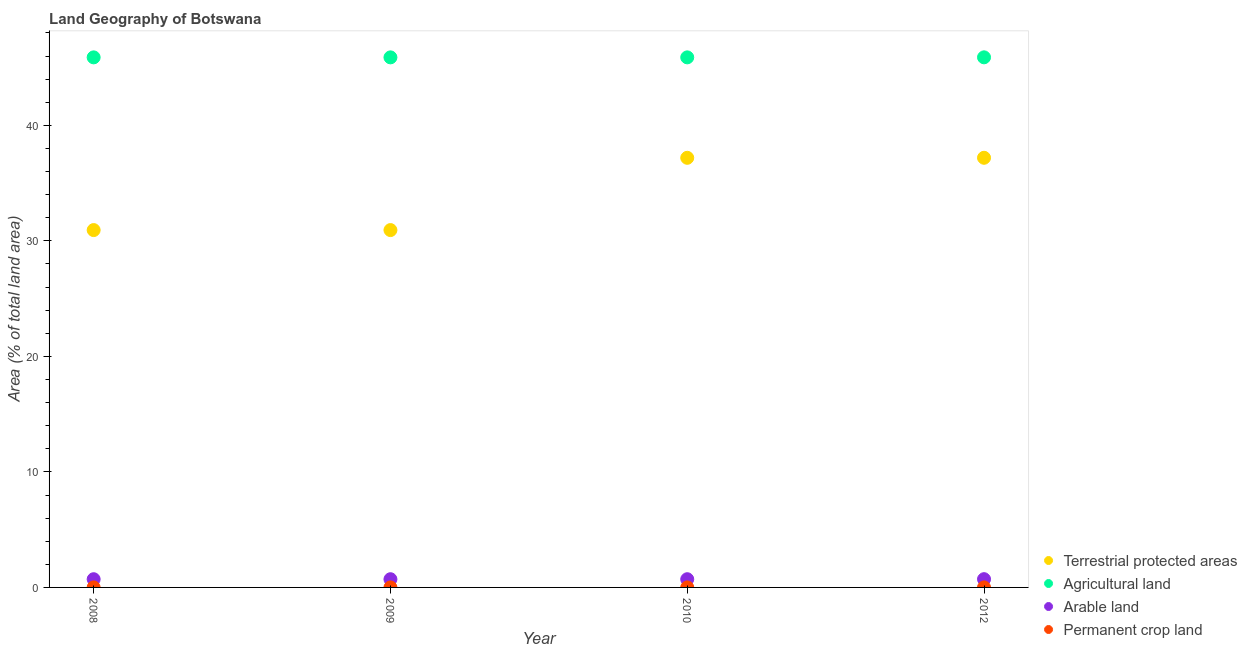Is the number of dotlines equal to the number of legend labels?
Ensure brevity in your answer.  Yes. What is the percentage of area under permanent crop land in 2012?
Give a very brief answer. 0. Across all years, what is the maximum percentage of area under permanent crop land?
Keep it short and to the point. 0. Across all years, what is the minimum percentage of area under arable land?
Offer a very short reply. 0.71. In which year was the percentage of land under terrestrial protection minimum?
Ensure brevity in your answer.  2008. What is the total percentage of area under arable land in the graph?
Provide a short and direct response. 2.85. What is the difference between the percentage of area under agricultural land in 2008 and that in 2012?
Offer a very short reply. -0. What is the difference between the percentage of area under arable land in 2010 and the percentage of area under permanent crop land in 2009?
Ensure brevity in your answer.  0.71. What is the average percentage of area under permanent crop land per year?
Keep it short and to the point. 0. In the year 2008, what is the difference between the percentage of area under arable land and percentage of area under agricultural land?
Provide a short and direct response. -45.17. In how many years, is the percentage of land under terrestrial protection greater than 16 %?
Offer a terse response. 4. What is the ratio of the percentage of land under terrestrial protection in 2010 to that in 2012?
Provide a short and direct response. 1. Is the percentage of area under permanent crop land in 2008 less than that in 2010?
Your response must be concise. No. Is the difference between the percentage of area under arable land in 2008 and 2010 greater than the difference between the percentage of area under permanent crop land in 2008 and 2010?
Offer a very short reply. No. What is the difference between the highest and the lowest percentage of land under terrestrial protection?
Offer a very short reply. 6.26. Is the sum of the percentage of land under terrestrial protection in 2009 and 2010 greater than the maximum percentage of area under agricultural land across all years?
Keep it short and to the point. Yes. Is the percentage of area under agricultural land strictly greater than the percentage of area under arable land over the years?
Your answer should be compact. Yes. What is the difference between two consecutive major ticks on the Y-axis?
Offer a terse response. 10. Are the values on the major ticks of Y-axis written in scientific E-notation?
Provide a succinct answer. No. Where does the legend appear in the graph?
Keep it short and to the point. Bottom right. How are the legend labels stacked?
Make the answer very short. Vertical. What is the title of the graph?
Offer a very short reply. Land Geography of Botswana. What is the label or title of the X-axis?
Provide a succinct answer. Year. What is the label or title of the Y-axis?
Your answer should be compact. Area (% of total land area). What is the Area (% of total land area) of Terrestrial protected areas in 2008?
Give a very brief answer. 30.93. What is the Area (% of total land area) in Agricultural land in 2008?
Your answer should be compact. 45.88. What is the Area (% of total land area) in Arable land in 2008?
Keep it short and to the point. 0.71. What is the Area (% of total land area) in Permanent crop land in 2008?
Your answer should be very brief. 0. What is the Area (% of total land area) of Terrestrial protected areas in 2009?
Offer a very short reply. 30.93. What is the Area (% of total land area) in Agricultural land in 2009?
Your response must be concise. 45.88. What is the Area (% of total land area) in Arable land in 2009?
Your answer should be compact. 0.71. What is the Area (% of total land area) in Permanent crop land in 2009?
Keep it short and to the point. 0. What is the Area (% of total land area) in Terrestrial protected areas in 2010?
Your answer should be compact. 37.19. What is the Area (% of total land area) in Agricultural land in 2010?
Offer a very short reply. 45.88. What is the Area (% of total land area) of Arable land in 2010?
Give a very brief answer. 0.71. What is the Area (% of total land area) of Permanent crop land in 2010?
Your answer should be very brief. 0. What is the Area (% of total land area) of Terrestrial protected areas in 2012?
Your answer should be very brief. 37.19. What is the Area (% of total land area) of Agricultural land in 2012?
Provide a succinct answer. 45.89. What is the Area (% of total land area) of Arable land in 2012?
Give a very brief answer. 0.71. What is the Area (% of total land area) of Permanent crop land in 2012?
Provide a short and direct response. 0. Across all years, what is the maximum Area (% of total land area) of Terrestrial protected areas?
Your answer should be very brief. 37.19. Across all years, what is the maximum Area (% of total land area) of Agricultural land?
Offer a very short reply. 45.89. Across all years, what is the maximum Area (% of total land area) in Arable land?
Your response must be concise. 0.71. Across all years, what is the maximum Area (% of total land area) in Permanent crop land?
Offer a terse response. 0. Across all years, what is the minimum Area (% of total land area) of Terrestrial protected areas?
Make the answer very short. 30.93. Across all years, what is the minimum Area (% of total land area) of Agricultural land?
Offer a very short reply. 45.88. Across all years, what is the minimum Area (% of total land area) of Arable land?
Give a very brief answer. 0.71. Across all years, what is the minimum Area (% of total land area) in Permanent crop land?
Ensure brevity in your answer.  0. What is the total Area (% of total land area) of Terrestrial protected areas in the graph?
Provide a short and direct response. 136.25. What is the total Area (% of total land area) in Agricultural land in the graph?
Your answer should be compact. 183.54. What is the total Area (% of total land area) in Arable land in the graph?
Keep it short and to the point. 2.85. What is the total Area (% of total land area) of Permanent crop land in the graph?
Your answer should be compact. 0.01. What is the difference between the Area (% of total land area) in Terrestrial protected areas in 2008 and that in 2009?
Keep it short and to the point. 0. What is the difference between the Area (% of total land area) of Terrestrial protected areas in 2008 and that in 2010?
Provide a short and direct response. -6.26. What is the difference between the Area (% of total land area) in Arable land in 2008 and that in 2010?
Ensure brevity in your answer.  0. What is the difference between the Area (% of total land area) in Permanent crop land in 2008 and that in 2010?
Ensure brevity in your answer.  0. What is the difference between the Area (% of total land area) of Terrestrial protected areas in 2008 and that in 2012?
Make the answer very short. -6.26. What is the difference between the Area (% of total land area) of Agricultural land in 2008 and that in 2012?
Your answer should be compact. -0. What is the difference between the Area (% of total land area) of Arable land in 2008 and that in 2012?
Provide a short and direct response. -0. What is the difference between the Area (% of total land area) in Terrestrial protected areas in 2009 and that in 2010?
Offer a very short reply. -6.26. What is the difference between the Area (% of total land area) of Terrestrial protected areas in 2009 and that in 2012?
Your response must be concise. -6.26. What is the difference between the Area (% of total land area) in Agricultural land in 2009 and that in 2012?
Provide a succinct answer. -0. What is the difference between the Area (% of total land area) in Arable land in 2009 and that in 2012?
Ensure brevity in your answer.  -0. What is the difference between the Area (% of total land area) in Terrestrial protected areas in 2010 and that in 2012?
Offer a terse response. -0. What is the difference between the Area (% of total land area) in Agricultural land in 2010 and that in 2012?
Offer a terse response. -0. What is the difference between the Area (% of total land area) in Arable land in 2010 and that in 2012?
Make the answer very short. -0. What is the difference between the Area (% of total land area) of Terrestrial protected areas in 2008 and the Area (% of total land area) of Agricultural land in 2009?
Provide a short and direct response. -14.95. What is the difference between the Area (% of total land area) of Terrestrial protected areas in 2008 and the Area (% of total land area) of Arable land in 2009?
Give a very brief answer. 30.22. What is the difference between the Area (% of total land area) of Terrestrial protected areas in 2008 and the Area (% of total land area) of Permanent crop land in 2009?
Keep it short and to the point. 30.93. What is the difference between the Area (% of total land area) in Agricultural land in 2008 and the Area (% of total land area) in Arable land in 2009?
Your answer should be compact. 45.17. What is the difference between the Area (% of total land area) of Agricultural land in 2008 and the Area (% of total land area) of Permanent crop land in 2009?
Give a very brief answer. 45.88. What is the difference between the Area (% of total land area) in Arable land in 2008 and the Area (% of total land area) in Permanent crop land in 2009?
Provide a short and direct response. 0.71. What is the difference between the Area (% of total land area) of Terrestrial protected areas in 2008 and the Area (% of total land area) of Agricultural land in 2010?
Keep it short and to the point. -14.95. What is the difference between the Area (% of total land area) in Terrestrial protected areas in 2008 and the Area (% of total land area) in Arable land in 2010?
Your response must be concise. 30.22. What is the difference between the Area (% of total land area) of Terrestrial protected areas in 2008 and the Area (% of total land area) of Permanent crop land in 2010?
Offer a terse response. 30.93. What is the difference between the Area (% of total land area) of Agricultural land in 2008 and the Area (% of total land area) of Arable land in 2010?
Offer a very short reply. 45.17. What is the difference between the Area (% of total land area) in Agricultural land in 2008 and the Area (% of total land area) in Permanent crop land in 2010?
Ensure brevity in your answer.  45.88. What is the difference between the Area (% of total land area) of Arable land in 2008 and the Area (% of total land area) of Permanent crop land in 2010?
Give a very brief answer. 0.71. What is the difference between the Area (% of total land area) of Terrestrial protected areas in 2008 and the Area (% of total land area) of Agricultural land in 2012?
Offer a very short reply. -14.95. What is the difference between the Area (% of total land area) in Terrestrial protected areas in 2008 and the Area (% of total land area) in Arable land in 2012?
Your response must be concise. 30.22. What is the difference between the Area (% of total land area) in Terrestrial protected areas in 2008 and the Area (% of total land area) in Permanent crop land in 2012?
Ensure brevity in your answer.  30.93. What is the difference between the Area (% of total land area) in Agricultural land in 2008 and the Area (% of total land area) in Arable land in 2012?
Provide a short and direct response. 45.17. What is the difference between the Area (% of total land area) in Agricultural land in 2008 and the Area (% of total land area) in Permanent crop land in 2012?
Offer a terse response. 45.88. What is the difference between the Area (% of total land area) of Arable land in 2008 and the Area (% of total land area) of Permanent crop land in 2012?
Make the answer very short. 0.71. What is the difference between the Area (% of total land area) of Terrestrial protected areas in 2009 and the Area (% of total land area) of Agricultural land in 2010?
Offer a very short reply. -14.95. What is the difference between the Area (% of total land area) in Terrestrial protected areas in 2009 and the Area (% of total land area) in Arable land in 2010?
Offer a terse response. 30.22. What is the difference between the Area (% of total land area) of Terrestrial protected areas in 2009 and the Area (% of total land area) of Permanent crop land in 2010?
Make the answer very short. 30.93. What is the difference between the Area (% of total land area) in Agricultural land in 2009 and the Area (% of total land area) in Arable land in 2010?
Ensure brevity in your answer.  45.17. What is the difference between the Area (% of total land area) of Agricultural land in 2009 and the Area (% of total land area) of Permanent crop land in 2010?
Give a very brief answer. 45.88. What is the difference between the Area (% of total land area) in Arable land in 2009 and the Area (% of total land area) in Permanent crop land in 2010?
Keep it short and to the point. 0.71. What is the difference between the Area (% of total land area) in Terrestrial protected areas in 2009 and the Area (% of total land area) in Agricultural land in 2012?
Make the answer very short. -14.95. What is the difference between the Area (% of total land area) in Terrestrial protected areas in 2009 and the Area (% of total land area) in Arable land in 2012?
Keep it short and to the point. 30.22. What is the difference between the Area (% of total land area) in Terrestrial protected areas in 2009 and the Area (% of total land area) in Permanent crop land in 2012?
Provide a succinct answer. 30.93. What is the difference between the Area (% of total land area) in Agricultural land in 2009 and the Area (% of total land area) in Arable land in 2012?
Give a very brief answer. 45.17. What is the difference between the Area (% of total land area) in Agricultural land in 2009 and the Area (% of total land area) in Permanent crop land in 2012?
Your response must be concise. 45.88. What is the difference between the Area (% of total land area) in Arable land in 2009 and the Area (% of total land area) in Permanent crop land in 2012?
Your answer should be compact. 0.71. What is the difference between the Area (% of total land area) of Terrestrial protected areas in 2010 and the Area (% of total land area) of Agricultural land in 2012?
Ensure brevity in your answer.  -8.7. What is the difference between the Area (% of total land area) in Terrestrial protected areas in 2010 and the Area (% of total land area) in Arable land in 2012?
Your response must be concise. 36.48. What is the difference between the Area (% of total land area) in Terrestrial protected areas in 2010 and the Area (% of total land area) in Permanent crop land in 2012?
Keep it short and to the point. 37.19. What is the difference between the Area (% of total land area) in Agricultural land in 2010 and the Area (% of total land area) in Arable land in 2012?
Give a very brief answer. 45.17. What is the difference between the Area (% of total land area) in Agricultural land in 2010 and the Area (% of total land area) in Permanent crop land in 2012?
Give a very brief answer. 45.88. What is the difference between the Area (% of total land area) in Arable land in 2010 and the Area (% of total land area) in Permanent crop land in 2012?
Your answer should be compact. 0.71. What is the average Area (% of total land area) of Terrestrial protected areas per year?
Ensure brevity in your answer.  34.06. What is the average Area (% of total land area) in Agricultural land per year?
Your answer should be compact. 45.89. What is the average Area (% of total land area) in Arable land per year?
Offer a terse response. 0.71. What is the average Area (% of total land area) in Permanent crop land per year?
Ensure brevity in your answer.  0. In the year 2008, what is the difference between the Area (% of total land area) of Terrestrial protected areas and Area (% of total land area) of Agricultural land?
Your response must be concise. -14.95. In the year 2008, what is the difference between the Area (% of total land area) of Terrestrial protected areas and Area (% of total land area) of Arable land?
Make the answer very short. 30.22. In the year 2008, what is the difference between the Area (% of total land area) in Terrestrial protected areas and Area (% of total land area) in Permanent crop land?
Offer a terse response. 30.93. In the year 2008, what is the difference between the Area (% of total land area) of Agricultural land and Area (% of total land area) of Arable land?
Provide a short and direct response. 45.17. In the year 2008, what is the difference between the Area (% of total land area) in Agricultural land and Area (% of total land area) in Permanent crop land?
Keep it short and to the point. 45.88. In the year 2008, what is the difference between the Area (% of total land area) of Arable land and Area (% of total land area) of Permanent crop land?
Offer a terse response. 0.71. In the year 2009, what is the difference between the Area (% of total land area) in Terrestrial protected areas and Area (% of total land area) in Agricultural land?
Give a very brief answer. -14.95. In the year 2009, what is the difference between the Area (% of total land area) of Terrestrial protected areas and Area (% of total land area) of Arable land?
Ensure brevity in your answer.  30.22. In the year 2009, what is the difference between the Area (% of total land area) in Terrestrial protected areas and Area (% of total land area) in Permanent crop land?
Offer a very short reply. 30.93. In the year 2009, what is the difference between the Area (% of total land area) in Agricultural land and Area (% of total land area) in Arable land?
Keep it short and to the point. 45.17. In the year 2009, what is the difference between the Area (% of total land area) in Agricultural land and Area (% of total land area) in Permanent crop land?
Offer a terse response. 45.88. In the year 2009, what is the difference between the Area (% of total land area) in Arable land and Area (% of total land area) in Permanent crop land?
Ensure brevity in your answer.  0.71. In the year 2010, what is the difference between the Area (% of total land area) of Terrestrial protected areas and Area (% of total land area) of Agricultural land?
Your answer should be very brief. -8.69. In the year 2010, what is the difference between the Area (% of total land area) in Terrestrial protected areas and Area (% of total land area) in Arable land?
Keep it short and to the point. 36.48. In the year 2010, what is the difference between the Area (% of total land area) of Terrestrial protected areas and Area (% of total land area) of Permanent crop land?
Give a very brief answer. 37.19. In the year 2010, what is the difference between the Area (% of total land area) in Agricultural land and Area (% of total land area) in Arable land?
Provide a succinct answer. 45.17. In the year 2010, what is the difference between the Area (% of total land area) of Agricultural land and Area (% of total land area) of Permanent crop land?
Your answer should be compact. 45.88. In the year 2010, what is the difference between the Area (% of total land area) of Arable land and Area (% of total land area) of Permanent crop land?
Make the answer very short. 0.71. In the year 2012, what is the difference between the Area (% of total land area) in Terrestrial protected areas and Area (% of total land area) in Agricultural land?
Your response must be concise. -8.7. In the year 2012, what is the difference between the Area (% of total land area) in Terrestrial protected areas and Area (% of total land area) in Arable land?
Offer a terse response. 36.48. In the year 2012, what is the difference between the Area (% of total land area) of Terrestrial protected areas and Area (% of total land area) of Permanent crop land?
Offer a very short reply. 37.19. In the year 2012, what is the difference between the Area (% of total land area) of Agricultural land and Area (% of total land area) of Arable land?
Give a very brief answer. 45.17. In the year 2012, what is the difference between the Area (% of total land area) of Agricultural land and Area (% of total land area) of Permanent crop land?
Give a very brief answer. 45.89. In the year 2012, what is the difference between the Area (% of total land area) in Arable land and Area (% of total land area) in Permanent crop land?
Offer a terse response. 0.71. What is the ratio of the Area (% of total land area) of Agricultural land in 2008 to that in 2009?
Your answer should be very brief. 1. What is the ratio of the Area (% of total land area) of Arable land in 2008 to that in 2009?
Keep it short and to the point. 1. What is the ratio of the Area (% of total land area) in Permanent crop land in 2008 to that in 2009?
Provide a succinct answer. 1. What is the ratio of the Area (% of total land area) in Terrestrial protected areas in 2008 to that in 2010?
Offer a very short reply. 0.83. What is the ratio of the Area (% of total land area) of Permanent crop land in 2008 to that in 2010?
Your answer should be very brief. 1. What is the ratio of the Area (% of total land area) in Terrestrial protected areas in 2008 to that in 2012?
Your answer should be compact. 0.83. What is the ratio of the Area (% of total land area) of Agricultural land in 2008 to that in 2012?
Give a very brief answer. 1. What is the ratio of the Area (% of total land area) in Arable land in 2008 to that in 2012?
Your answer should be compact. 1. What is the ratio of the Area (% of total land area) in Terrestrial protected areas in 2009 to that in 2010?
Ensure brevity in your answer.  0.83. What is the ratio of the Area (% of total land area) in Arable land in 2009 to that in 2010?
Offer a terse response. 1. What is the ratio of the Area (% of total land area) of Permanent crop land in 2009 to that in 2010?
Your answer should be compact. 1. What is the ratio of the Area (% of total land area) in Terrestrial protected areas in 2009 to that in 2012?
Ensure brevity in your answer.  0.83. What is the ratio of the Area (% of total land area) in Permanent crop land in 2009 to that in 2012?
Offer a terse response. 1. What is the ratio of the Area (% of total land area) in Terrestrial protected areas in 2010 to that in 2012?
Provide a succinct answer. 1. What is the ratio of the Area (% of total land area) of Arable land in 2010 to that in 2012?
Keep it short and to the point. 1. What is the ratio of the Area (% of total land area) in Permanent crop land in 2010 to that in 2012?
Ensure brevity in your answer.  1. What is the difference between the highest and the second highest Area (% of total land area) in Terrestrial protected areas?
Provide a succinct answer. 0. What is the difference between the highest and the second highest Area (% of total land area) of Agricultural land?
Keep it short and to the point. 0. What is the difference between the highest and the second highest Area (% of total land area) in Arable land?
Your answer should be compact. 0. What is the difference between the highest and the lowest Area (% of total land area) in Terrestrial protected areas?
Keep it short and to the point. 6.26. What is the difference between the highest and the lowest Area (% of total land area) of Agricultural land?
Give a very brief answer. 0. What is the difference between the highest and the lowest Area (% of total land area) in Arable land?
Offer a very short reply. 0. What is the difference between the highest and the lowest Area (% of total land area) in Permanent crop land?
Your answer should be very brief. 0. 